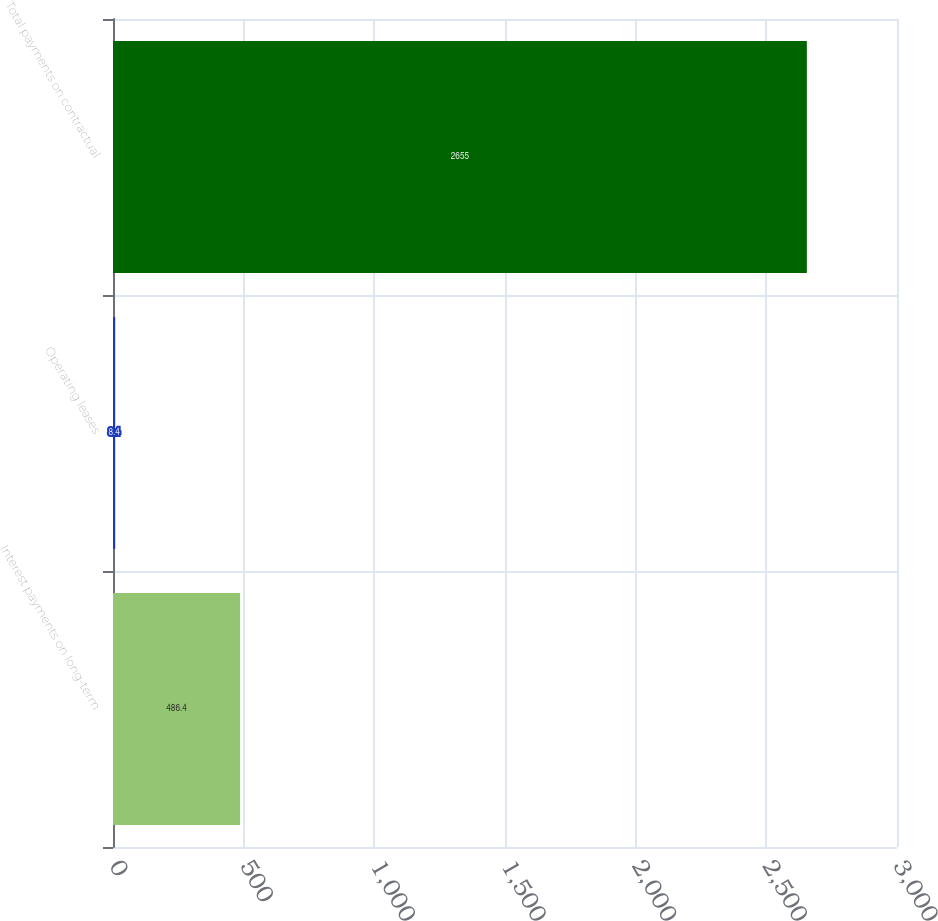Convert chart. <chart><loc_0><loc_0><loc_500><loc_500><bar_chart><fcel>Interest payments on long-term<fcel>Operating leases<fcel>Total payments on contractual<nl><fcel>486.4<fcel>8.4<fcel>2655<nl></chart> 